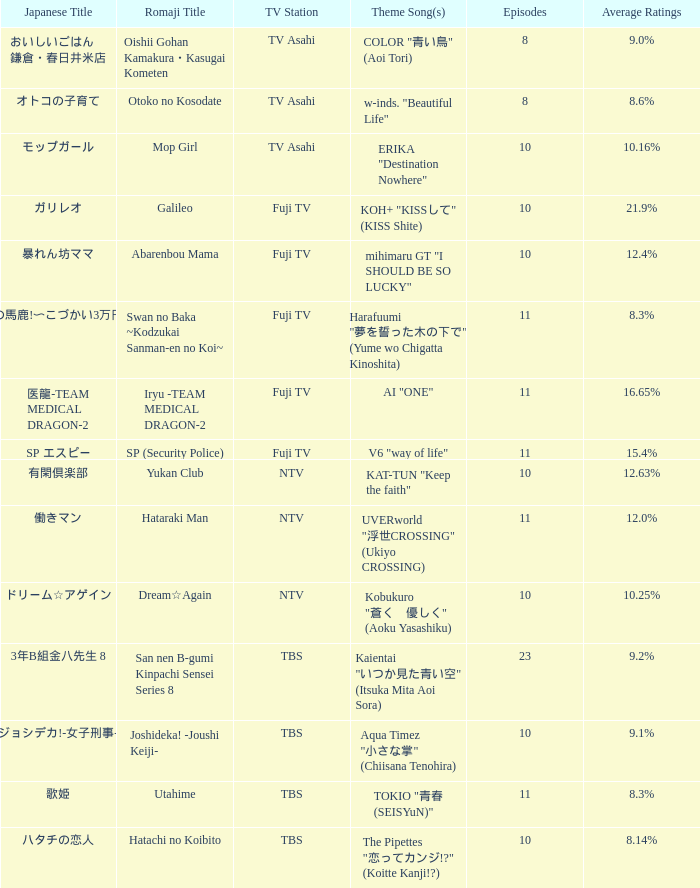What is the Theme Song of 働きマン? UVERworld "浮世CROSSING" (Ukiyo CROSSING). 